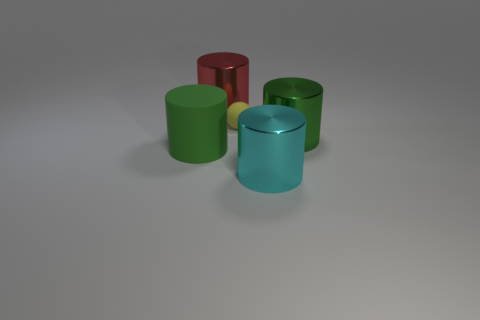There is a green cylinder that is right of the tiny yellow rubber ball; what number of green metallic cylinders are behind it?
Provide a succinct answer. 0. Are there fewer tiny things right of the ball than cyan cylinders?
Your answer should be very brief. Yes. Are there any big objects that are to the right of the green object behind the cylinder that is to the left of the large red metallic object?
Your answer should be compact. No. Does the yellow sphere have the same material as the green cylinder that is right of the small matte sphere?
Make the answer very short. No. What is the color of the large cylinder to the left of the shiny object that is on the left side of the cyan object?
Provide a succinct answer. Green. Is there a small thing that has the same color as the tiny matte ball?
Offer a terse response. No. What size is the green cylinder on the left side of the large green cylinder that is right of the metallic cylinder that is behind the matte sphere?
Your response must be concise. Large. There is a yellow matte thing; does it have the same shape as the green thing that is left of the cyan metallic object?
Offer a terse response. No. How many other objects are the same size as the cyan metallic cylinder?
Give a very brief answer. 3. There is a rubber object that is right of the large rubber cylinder; how big is it?
Provide a short and direct response. Small. 